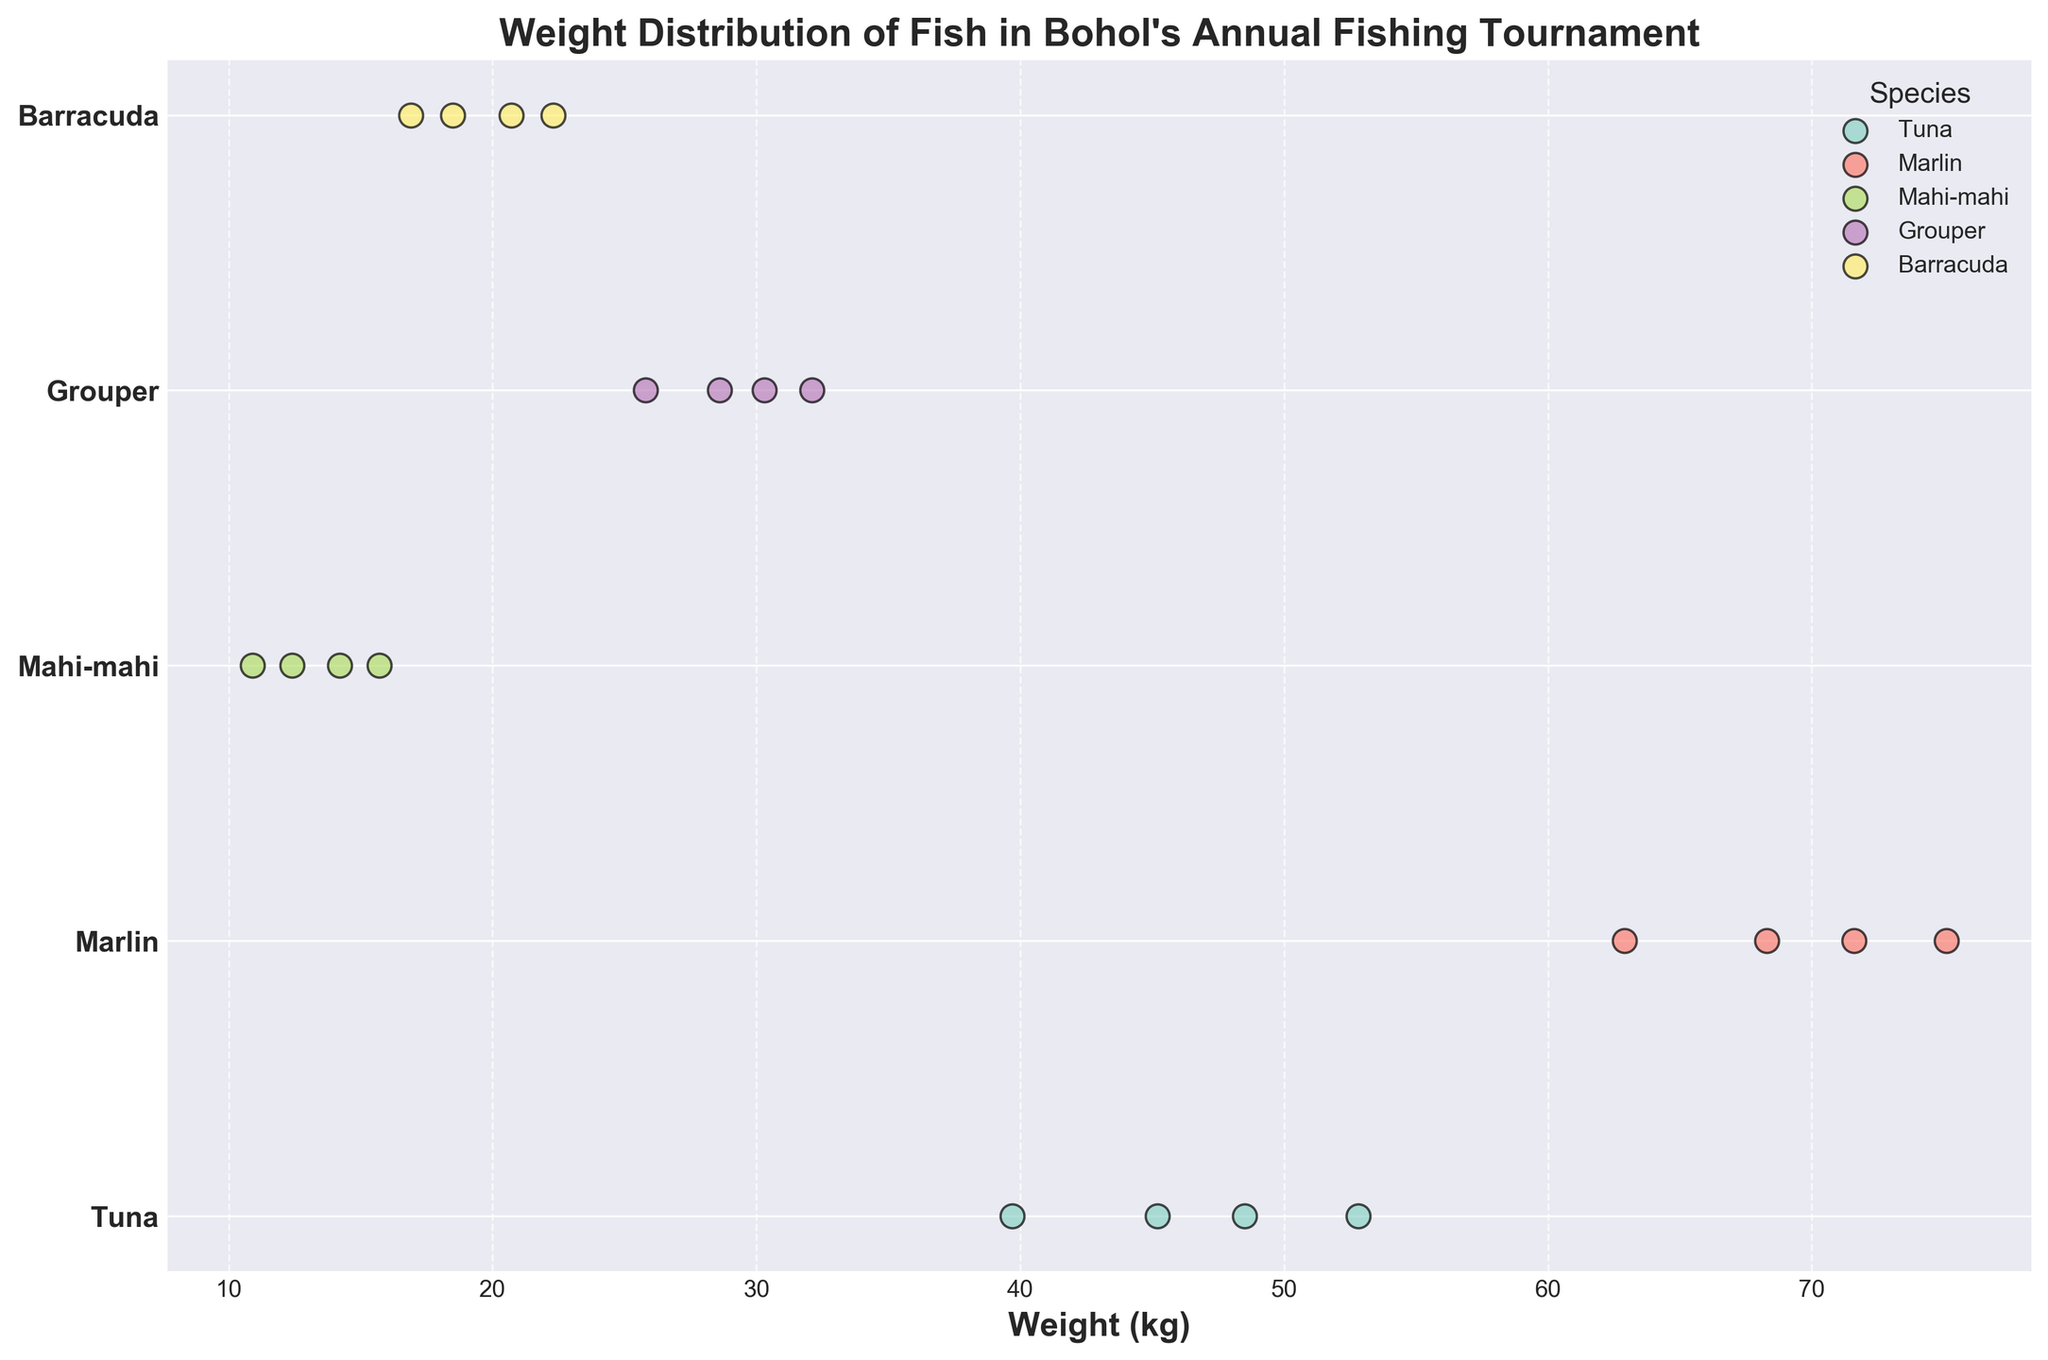What's the title of the figure? The title is usually placed at the top of the figure, and in this case, it reads "Weight Distribution of Fish in Bohol's Annual Fishing Tournament" as seen in the center above the plot.
Answer: Weight Distribution of Fish in Bohol's Annual Fishing Tournament How are different species represented in the plot? Different species are represented using various colors. This can be observed from the scatter points with unique colors for each species. The legend indicates which color corresponds to which species.
Answer: By different colors What is the range of weights for Tuna? By observing the scatter points representing Tuna, they appear between approximately 39.7 kg and 52.8 kg, so the range can be calculated.
Answer: Approximately 39.7 kg to 52.8 kg Which species has the highest weight recorded in the tournament? Look at the topmost points on the x-axis for each species and note the weight values. Marlin has the highest weight recorded at 75.1 kg.
Answer: Marlin Which species has the smallest range of weights? Compare the distribution (spread) of scatter points for each species on the x-axis. Mahi-mahi shows the smallest spread in weight values, ranging around 10.9 kg to 15.7 kg.
Answer: Mahi-mahi How many data points are there for each species? By counting the scatter points for each species in the plot, we find each of Tuna, Marlin, Mahi-mahi, Grouper, and Barracuda has 4 points. Thus, each species has 4 data points.
Answer: 4 for each species What is the overall weight difference between the heaviest Marlin and the heaviest Tuna? The heaviest Marlin weighs 75.1 kg and the heaviest Tuna weighs 52.8 kg. Subtracting these two values gives us the weight difference.
Answer: 22.3 kg Which species has weights that are most clustered together (close to each other)? Observe the density and spread of the scatter points horizontally. The species with weights that appear most clustered together, indicating less spread in weights, is Mahi-mahi.
Answer: Mahi-mahi Is there any overlap in weight between Barracuda and Grouper? Visual inspection of the scatter points for Barracuda and Grouper indicates there's no overlap as Barracuda weights range from 16.9 kg to 22.3 kg and Grouper weights range from 25.8 kg to 32.1 kg.
Answer: No 